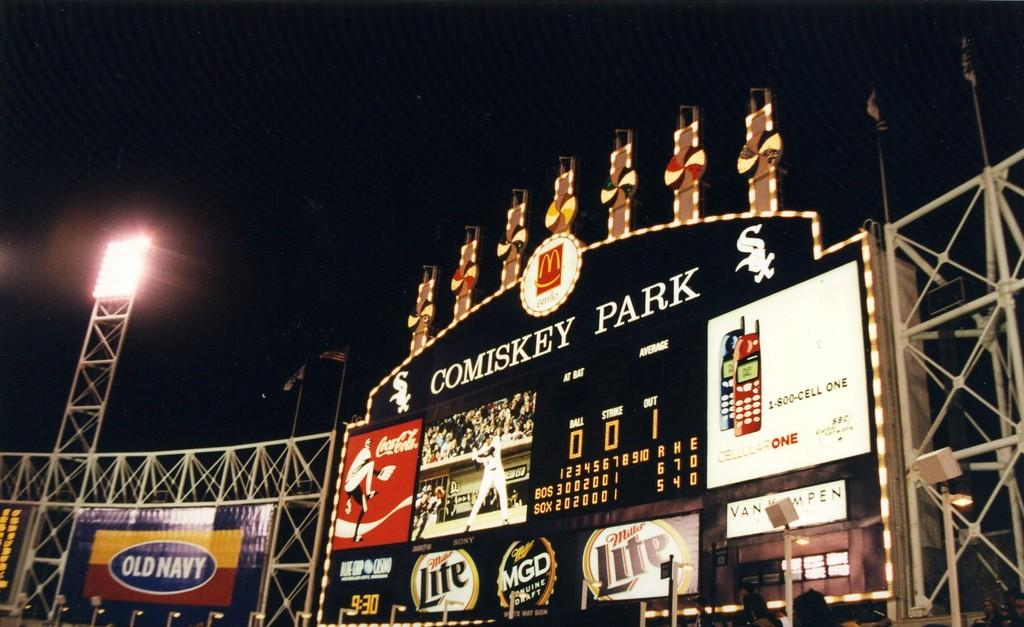<image>
Share a concise interpretation of the image provided. Scoreboard inside a baseball stadium which has an ad for MGD. 